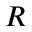<formula> <loc_0><loc_0><loc_500><loc_500>R</formula> 